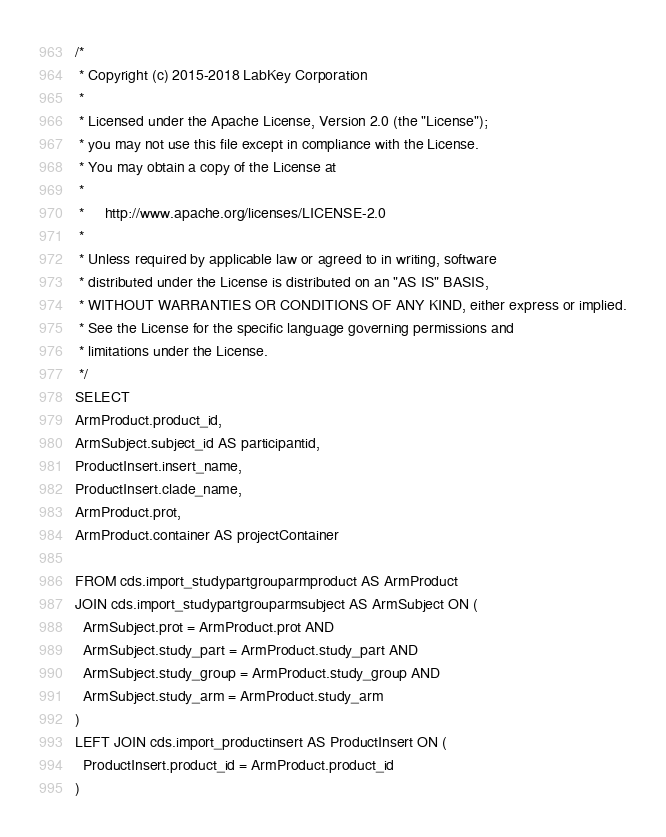Convert code to text. <code><loc_0><loc_0><loc_500><loc_500><_SQL_>/*
 * Copyright (c) 2015-2018 LabKey Corporation
 *
 * Licensed under the Apache License, Version 2.0 (the "License");
 * you may not use this file except in compliance with the License.
 * You may obtain a copy of the License at
 *
 *     http://www.apache.org/licenses/LICENSE-2.0
 *
 * Unless required by applicable law or agreed to in writing, software
 * distributed under the License is distributed on an "AS IS" BASIS,
 * WITHOUT WARRANTIES OR CONDITIONS OF ANY KIND, either express or implied.
 * See the License for the specific language governing permissions and
 * limitations under the License.
 */
SELECT
ArmProduct.product_id,
ArmSubject.subject_id AS participantid,
ProductInsert.insert_name,
ProductInsert.clade_name,
ArmProduct.prot,
ArmProduct.container AS projectContainer

FROM cds.import_studypartgrouparmproduct AS ArmProduct
JOIN cds.import_studypartgrouparmsubject AS ArmSubject ON (
  ArmSubject.prot = ArmProduct.prot AND
  ArmSubject.study_part = ArmProduct.study_part AND
  ArmSubject.study_group = ArmProduct.study_group AND
  ArmSubject.study_arm = ArmProduct.study_arm
)
LEFT JOIN cds.import_productinsert AS ProductInsert ON (
  ProductInsert.product_id = ArmProduct.product_id
)</code> 